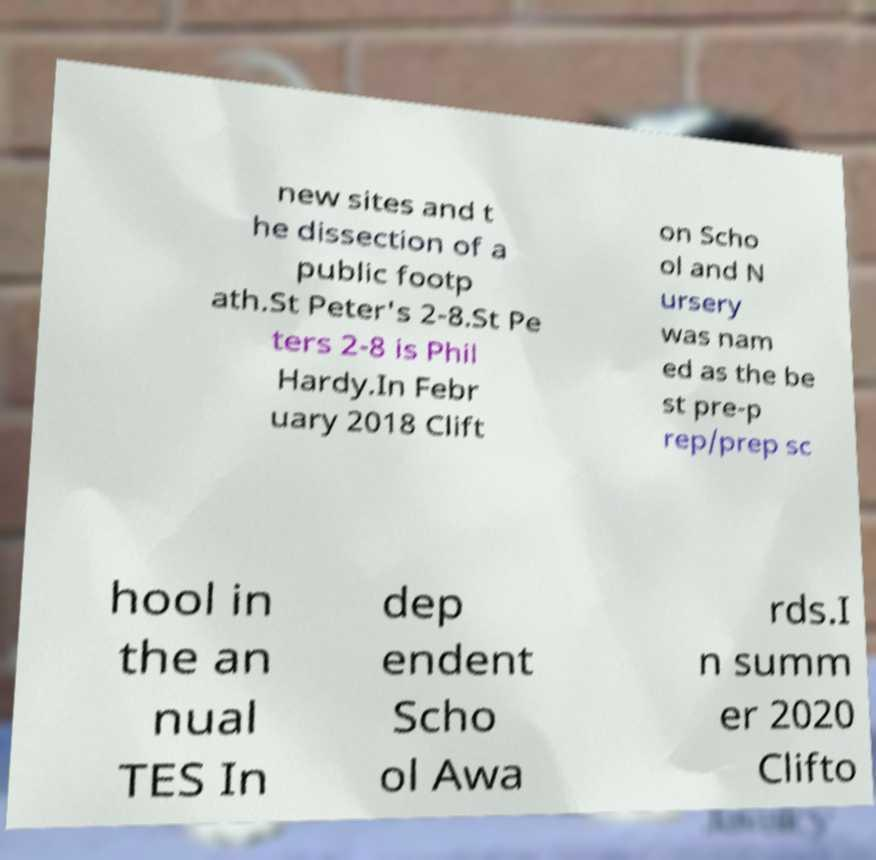There's text embedded in this image that I need extracted. Can you transcribe it verbatim? new sites and t he dissection of a public footp ath.St Peter's 2-8.St Pe ters 2-8 is Phil Hardy.In Febr uary 2018 Clift on Scho ol and N ursery was nam ed as the be st pre-p rep/prep sc hool in the an nual TES In dep endent Scho ol Awa rds.I n summ er 2020 Clifto 